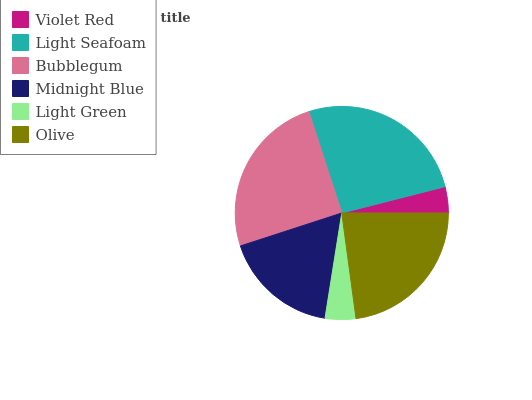Is Violet Red the minimum?
Answer yes or no. Yes. Is Light Seafoam the maximum?
Answer yes or no. Yes. Is Bubblegum the minimum?
Answer yes or no. No. Is Bubblegum the maximum?
Answer yes or no. No. Is Light Seafoam greater than Bubblegum?
Answer yes or no. Yes. Is Bubblegum less than Light Seafoam?
Answer yes or no. Yes. Is Bubblegum greater than Light Seafoam?
Answer yes or no. No. Is Light Seafoam less than Bubblegum?
Answer yes or no. No. Is Olive the high median?
Answer yes or no. Yes. Is Midnight Blue the low median?
Answer yes or no. Yes. Is Bubblegum the high median?
Answer yes or no. No. Is Olive the low median?
Answer yes or no. No. 